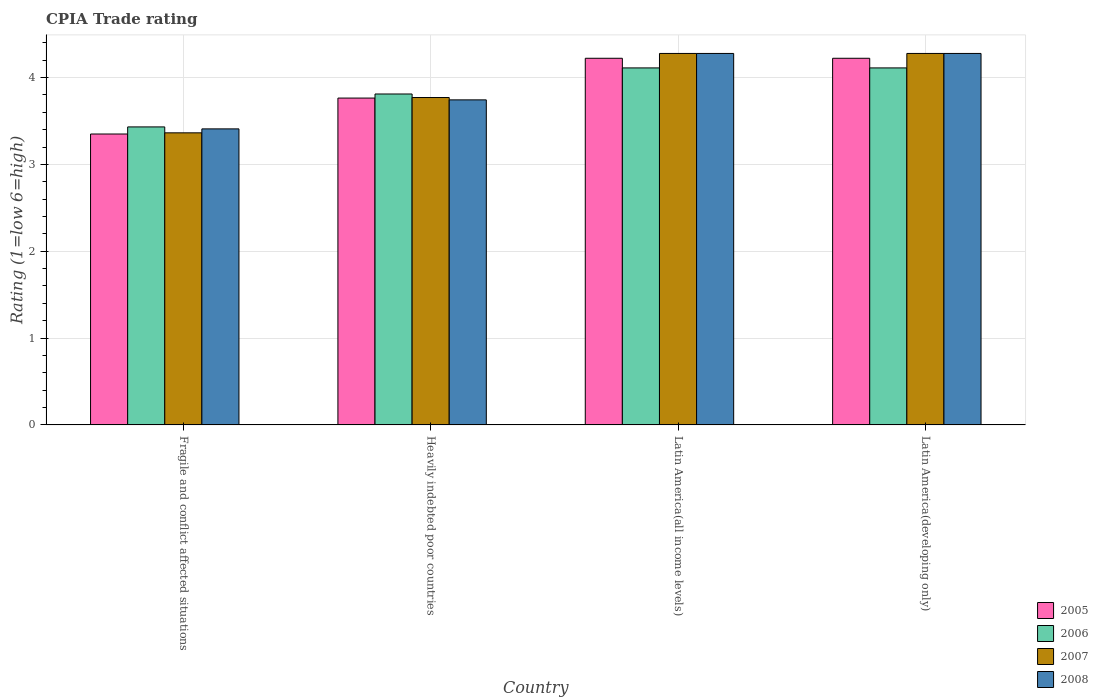How many different coloured bars are there?
Provide a succinct answer. 4. Are the number of bars per tick equal to the number of legend labels?
Provide a succinct answer. Yes. Are the number of bars on each tick of the X-axis equal?
Make the answer very short. Yes. How many bars are there on the 4th tick from the right?
Make the answer very short. 4. What is the label of the 4th group of bars from the left?
Give a very brief answer. Latin America(developing only). What is the CPIA rating in 2006 in Latin America(developing only)?
Provide a short and direct response. 4.11. Across all countries, what is the maximum CPIA rating in 2008?
Keep it short and to the point. 4.28. Across all countries, what is the minimum CPIA rating in 2006?
Your answer should be very brief. 3.43. In which country was the CPIA rating in 2008 maximum?
Offer a very short reply. Latin America(all income levels). In which country was the CPIA rating in 2005 minimum?
Provide a succinct answer. Fragile and conflict affected situations. What is the total CPIA rating in 2005 in the graph?
Your answer should be very brief. 15.56. What is the difference between the CPIA rating in 2007 in Heavily indebted poor countries and that in Latin America(developing only)?
Ensure brevity in your answer.  -0.51. What is the difference between the CPIA rating in 2006 in Fragile and conflict affected situations and the CPIA rating in 2007 in Latin America(all income levels)?
Your answer should be compact. -0.85. What is the average CPIA rating in 2008 per country?
Provide a short and direct response. 3.93. What is the difference between the CPIA rating of/in 2008 and CPIA rating of/in 2005 in Heavily indebted poor countries?
Your answer should be very brief. -0.02. In how many countries, is the CPIA rating in 2005 greater than 0.4?
Make the answer very short. 4. What is the ratio of the CPIA rating in 2006 in Fragile and conflict affected situations to that in Latin America(all income levels)?
Provide a succinct answer. 0.83. Is the difference between the CPIA rating in 2008 in Fragile and conflict affected situations and Latin America(all income levels) greater than the difference between the CPIA rating in 2005 in Fragile and conflict affected situations and Latin America(all income levels)?
Your answer should be compact. Yes. What is the difference between the highest and the second highest CPIA rating in 2008?
Your answer should be very brief. -0.53. What is the difference between the highest and the lowest CPIA rating in 2007?
Give a very brief answer. 0.91. In how many countries, is the CPIA rating in 2008 greater than the average CPIA rating in 2008 taken over all countries?
Keep it short and to the point. 2. What does the 3rd bar from the right in Latin America(all income levels) represents?
Make the answer very short. 2006. Is it the case that in every country, the sum of the CPIA rating in 2006 and CPIA rating in 2008 is greater than the CPIA rating in 2005?
Your answer should be very brief. Yes. How many bars are there?
Your answer should be very brief. 16. How many countries are there in the graph?
Offer a very short reply. 4. What is the difference between two consecutive major ticks on the Y-axis?
Give a very brief answer. 1. Does the graph contain any zero values?
Your answer should be very brief. No. How many legend labels are there?
Make the answer very short. 4. What is the title of the graph?
Make the answer very short. CPIA Trade rating. Does "1988" appear as one of the legend labels in the graph?
Offer a terse response. No. What is the label or title of the X-axis?
Keep it short and to the point. Country. What is the Rating (1=low 6=high) in 2005 in Fragile and conflict affected situations?
Your answer should be compact. 3.35. What is the Rating (1=low 6=high) of 2006 in Fragile and conflict affected situations?
Offer a terse response. 3.43. What is the Rating (1=low 6=high) of 2007 in Fragile and conflict affected situations?
Offer a terse response. 3.36. What is the Rating (1=low 6=high) in 2008 in Fragile and conflict affected situations?
Make the answer very short. 3.41. What is the Rating (1=low 6=high) in 2005 in Heavily indebted poor countries?
Provide a short and direct response. 3.76. What is the Rating (1=low 6=high) in 2006 in Heavily indebted poor countries?
Give a very brief answer. 3.81. What is the Rating (1=low 6=high) of 2007 in Heavily indebted poor countries?
Your answer should be very brief. 3.77. What is the Rating (1=low 6=high) in 2008 in Heavily indebted poor countries?
Offer a very short reply. 3.74. What is the Rating (1=low 6=high) of 2005 in Latin America(all income levels)?
Offer a terse response. 4.22. What is the Rating (1=low 6=high) in 2006 in Latin America(all income levels)?
Ensure brevity in your answer.  4.11. What is the Rating (1=low 6=high) in 2007 in Latin America(all income levels)?
Ensure brevity in your answer.  4.28. What is the Rating (1=low 6=high) in 2008 in Latin America(all income levels)?
Offer a very short reply. 4.28. What is the Rating (1=low 6=high) of 2005 in Latin America(developing only)?
Ensure brevity in your answer.  4.22. What is the Rating (1=low 6=high) of 2006 in Latin America(developing only)?
Offer a very short reply. 4.11. What is the Rating (1=low 6=high) in 2007 in Latin America(developing only)?
Your answer should be compact. 4.28. What is the Rating (1=low 6=high) of 2008 in Latin America(developing only)?
Offer a terse response. 4.28. Across all countries, what is the maximum Rating (1=low 6=high) of 2005?
Keep it short and to the point. 4.22. Across all countries, what is the maximum Rating (1=low 6=high) in 2006?
Ensure brevity in your answer.  4.11. Across all countries, what is the maximum Rating (1=low 6=high) in 2007?
Offer a terse response. 4.28. Across all countries, what is the maximum Rating (1=low 6=high) in 2008?
Provide a short and direct response. 4.28. Across all countries, what is the minimum Rating (1=low 6=high) of 2005?
Give a very brief answer. 3.35. Across all countries, what is the minimum Rating (1=low 6=high) in 2006?
Ensure brevity in your answer.  3.43. Across all countries, what is the minimum Rating (1=low 6=high) of 2007?
Provide a short and direct response. 3.36. Across all countries, what is the minimum Rating (1=low 6=high) in 2008?
Provide a short and direct response. 3.41. What is the total Rating (1=low 6=high) in 2005 in the graph?
Your answer should be compact. 15.56. What is the total Rating (1=low 6=high) in 2006 in the graph?
Provide a short and direct response. 15.46. What is the total Rating (1=low 6=high) in 2007 in the graph?
Offer a terse response. 15.69. What is the total Rating (1=low 6=high) in 2008 in the graph?
Your answer should be compact. 15.71. What is the difference between the Rating (1=low 6=high) in 2005 in Fragile and conflict affected situations and that in Heavily indebted poor countries?
Provide a short and direct response. -0.41. What is the difference between the Rating (1=low 6=high) of 2006 in Fragile and conflict affected situations and that in Heavily indebted poor countries?
Keep it short and to the point. -0.38. What is the difference between the Rating (1=low 6=high) of 2007 in Fragile and conflict affected situations and that in Heavily indebted poor countries?
Your answer should be compact. -0.41. What is the difference between the Rating (1=low 6=high) in 2008 in Fragile and conflict affected situations and that in Heavily indebted poor countries?
Your answer should be very brief. -0.33. What is the difference between the Rating (1=low 6=high) of 2005 in Fragile and conflict affected situations and that in Latin America(all income levels)?
Your answer should be very brief. -0.87. What is the difference between the Rating (1=low 6=high) of 2006 in Fragile and conflict affected situations and that in Latin America(all income levels)?
Your response must be concise. -0.68. What is the difference between the Rating (1=low 6=high) of 2007 in Fragile and conflict affected situations and that in Latin America(all income levels)?
Give a very brief answer. -0.91. What is the difference between the Rating (1=low 6=high) in 2008 in Fragile and conflict affected situations and that in Latin America(all income levels)?
Your response must be concise. -0.87. What is the difference between the Rating (1=low 6=high) in 2005 in Fragile and conflict affected situations and that in Latin America(developing only)?
Provide a short and direct response. -0.87. What is the difference between the Rating (1=low 6=high) of 2006 in Fragile and conflict affected situations and that in Latin America(developing only)?
Your answer should be very brief. -0.68. What is the difference between the Rating (1=low 6=high) of 2007 in Fragile and conflict affected situations and that in Latin America(developing only)?
Provide a short and direct response. -0.91. What is the difference between the Rating (1=low 6=high) in 2008 in Fragile and conflict affected situations and that in Latin America(developing only)?
Your response must be concise. -0.87. What is the difference between the Rating (1=low 6=high) in 2005 in Heavily indebted poor countries and that in Latin America(all income levels)?
Provide a short and direct response. -0.46. What is the difference between the Rating (1=low 6=high) in 2006 in Heavily indebted poor countries and that in Latin America(all income levels)?
Provide a short and direct response. -0.3. What is the difference between the Rating (1=low 6=high) in 2007 in Heavily indebted poor countries and that in Latin America(all income levels)?
Your answer should be very brief. -0.51. What is the difference between the Rating (1=low 6=high) in 2008 in Heavily indebted poor countries and that in Latin America(all income levels)?
Your answer should be compact. -0.53. What is the difference between the Rating (1=low 6=high) of 2005 in Heavily indebted poor countries and that in Latin America(developing only)?
Your answer should be very brief. -0.46. What is the difference between the Rating (1=low 6=high) of 2006 in Heavily indebted poor countries and that in Latin America(developing only)?
Give a very brief answer. -0.3. What is the difference between the Rating (1=low 6=high) in 2007 in Heavily indebted poor countries and that in Latin America(developing only)?
Keep it short and to the point. -0.51. What is the difference between the Rating (1=low 6=high) in 2008 in Heavily indebted poor countries and that in Latin America(developing only)?
Ensure brevity in your answer.  -0.53. What is the difference between the Rating (1=low 6=high) in 2007 in Latin America(all income levels) and that in Latin America(developing only)?
Your answer should be compact. 0. What is the difference between the Rating (1=low 6=high) of 2005 in Fragile and conflict affected situations and the Rating (1=low 6=high) of 2006 in Heavily indebted poor countries?
Make the answer very short. -0.46. What is the difference between the Rating (1=low 6=high) of 2005 in Fragile and conflict affected situations and the Rating (1=low 6=high) of 2007 in Heavily indebted poor countries?
Provide a succinct answer. -0.42. What is the difference between the Rating (1=low 6=high) of 2005 in Fragile and conflict affected situations and the Rating (1=low 6=high) of 2008 in Heavily indebted poor countries?
Provide a short and direct response. -0.39. What is the difference between the Rating (1=low 6=high) of 2006 in Fragile and conflict affected situations and the Rating (1=low 6=high) of 2007 in Heavily indebted poor countries?
Offer a terse response. -0.34. What is the difference between the Rating (1=low 6=high) in 2006 in Fragile and conflict affected situations and the Rating (1=low 6=high) in 2008 in Heavily indebted poor countries?
Offer a terse response. -0.31. What is the difference between the Rating (1=low 6=high) of 2007 in Fragile and conflict affected situations and the Rating (1=low 6=high) of 2008 in Heavily indebted poor countries?
Your response must be concise. -0.38. What is the difference between the Rating (1=low 6=high) in 2005 in Fragile and conflict affected situations and the Rating (1=low 6=high) in 2006 in Latin America(all income levels)?
Provide a short and direct response. -0.76. What is the difference between the Rating (1=low 6=high) of 2005 in Fragile and conflict affected situations and the Rating (1=low 6=high) of 2007 in Latin America(all income levels)?
Provide a short and direct response. -0.93. What is the difference between the Rating (1=low 6=high) of 2005 in Fragile and conflict affected situations and the Rating (1=low 6=high) of 2008 in Latin America(all income levels)?
Make the answer very short. -0.93. What is the difference between the Rating (1=low 6=high) of 2006 in Fragile and conflict affected situations and the Rating (1=low 6=high) of 2007 in Latin America(all income levels)?
Give a very brief answer. -0.85. What is the difference between the Rating (1=low 6=high) of 2006 in Fragile and conflict affected situations and the Rating (1=low 6=high) of 2008 in Latin America(all income levels)?
Provide a short and direct response. -0.85. What is the difference between the Rating (1=low 6=high) in 2007 in Fragile and conflict affected situations and the Rating (1=low 6=high) in 2008 in Latin America(all income levels)?
Ensure brevity in your answer.  -0.91. What is the difference between the Rating (1=low 6=high) of 2005 in Fragile and conflict affected situations and the Rating (1=low 6=high) of 2006 in Latin America(developing only)?
Keep it short and to the point. -0.76. What is the difference between the Rating (1=low 6=high) in 2005 in Fragile and conflict affected situations and the Rating (1=low 6=high) in 2007 in Latin America(developing only)?
Make the answer very short. -0.93. What is the difference between the Rating (1=low 6=high) in 2005 in Fragile and conflict affected situations and the Rating (1=low 6=high) in 2008 in Latin America(developing only)?
Your response must be concise. -0.93. What is the difference between the Rating (1=low 6=high) in 2006 in Fragile and conflict affected situations and the Rating (1=low 6=high) in 2007 in Latin America(developing only)?
Provide a short and direct response. -0.85. What is the difference between the Rating (1=low 6=high) in 2006 in Fragile and conflict affected situations and the Rating (1=low 6=high) in 2008 in Latin America(developing only)?
Your response must be concise. -0.85. What is the difference between the Rating (1=low 6=high) in 2007 in Fragile and conflict affected situations and the Rating (1=low 6=high) in 2008 in Latin America(developing only)?
Give a very brief answer. -0.91. What is the difference between the Rating (1=low 6=high) of 2005 in Heavily indebted poor countries and the Rating (1=low 6=high) of 2006 in Latin America(all income levels)?
Keep it short and to the point. -0.35. What is the difference between the Rating (1=low 6=high) in 2005 in Heavily indebted poor countries and the Rating (1=low 6=high) in 2007 in Latin America(all income levels)?
Your response must be concise. -0.51. What is the difference between the Rating (1=low 6=high) of 2005 in Heavily indebted poor countries and the Rating (1=low 6=high) of 2008 in Latin America(all income levels)?
Provide a succinct answer. -0.51. What is the difference between the Rating (1=low 6=high) in 2006 in Heavily indebted poor countries and the Rating (1=low 6=high) in 2007 in Latin America(all income levels)?
Your response must be concise. -0.47. What is the difference between the Rating (1=low 6=high) of 2006 in Heavily indebted poor countries and the Rating (1=low 6=high) of 2008 in Latin America(all income levels)?
Your answer should be very brief. -0.47. What is the difference between the Rating (1=low 6=high) in 2007 in Heavily indebted poor countries and the Rating (1=low 6=high) in 2008 in Latin America(all income levels)?
Ensure brevity in your answer.  -0.51. What is the difference between the Rating (1=low 6=high) of 2005 in Heavily indebted poor countries and the Rating (1=low 6=high) of 2006 in Latin America(developing only)?
Give a very brief answer. -0.35. What is the difference between the Rating (1=low 6=high) of 2005 in Heavily indebted poor countries and the Rating (1=low 6=high) of 2007 in Latin America(developing only)?
Your response must be concise. -0.51. What is the difference between the Rating (1=low 6=high) in 2005 in Heavily indebted poor countries and the Rating (1=low 6=high) in 2008 in Latin America(developing only)?
Offer a terse response. -0.51. What is the difference between the Rating (1=low 6=high) of 2006 in Heavily indebted poor countries and the Rating (1=low 6=high) of 2007 in Latin America(developing only)?
Offer a very short reply. -0.47. What is the difference between the Rating (1=low 6=high) of 2006 in Heavily indebted poor countries and the Rating (1=low 6=high) of 2008 in Latin America(developing only)?
Your response must be concise. -0.47. What is the difference between the Rating (1=low 6=high) of 2007 in Heavily indebted poor countries and the Rating (1=low 6=high) of 2008 in Latin America(developing only)?
Provide a succinct answer. -0.51. What is the difference between the Rating (1=low 6=high) of 2005 in Latin America(all income levels) and the Rating (1=low 6=high) of 2007 in Latin America(developing only)?
Your answer should be compact. -0.06. What is the difference between the Rating (1=low 6=high) of 2005 in Latin America(all income levels) and the Rating (1=low 6=high) of 2008 in Latin America(developing only)?
Keep it short and to the point. -0.06. What is the difference between the Rating (1=low 6=high) in 2006 in Latin America(all income levels) and the Rating (1=low 6=high) in 2008 in Latin America(developing only)?
Your answer should be very brief. -0.17. What is the difference between the Rating (1=low 6=high) in 2007 in Latin America(all income levels) and the Rating (1=low 6=high) in 2008 in Latin America(developing only)?
Keep it short and to the point. 0. What is the average Rating (1=low 6=high) of 2005 per country?
Offer a terse response. 3.89. What is the average Rating (1=low 6=high) of 2006 per country?
Keep it short and to the point. 3.87. What is the average Rating (1=low 6=high) of 2007 per country?
Keep it short and to the point. 3.92. What is the average Rating (1=low 6=high) of 2008 per country?
Provide a short and direct response. 3.93. What is the difference between the Rating (1=low 6=high) of 2005 and Rating (1=low 6=high) of 2006 in Fragile and conflict affected situations?
Make the answer very short. -0.08. What is the difference between the Rating (1=low 6=high) in 2005 and Rating (1=low 6=high) in 2007 in Fragile and conflict affected situations?
Keep it short and to the point. -0.01. What is the difference between the Rating (1=low 6=high) of 2005 and Rating (1=low 6=high) of 2008 in Fragile and conflict affected situations?
Provide a short and direct response. -0.06. What is the difference between the Rating (1=low 6=high) in 2006 and Rating (1=low 6=high) in 2007 in Fragile and conflict affected situations?
Your response must be concise. 0.07. What is the difference between the Rating (1=low 6=high) in 2006 and Rating (1=low 6=high) in 2008 in Fragile and conflict affected situations?
Offer a terse response. 0.02. What is the difference between the Rating (1=low 6=high) of 2007 and Rating (1=low 6=high) of 2008 in Fragile and conflict affected situations?
Provide a short and direct response. -0.05. What is the difference between the Rating (1=low 6=high) in 2005 and Rating (1=low 6=high) in 2006 in Heavily indebted poor countries?
Your answer should be compact. -0.05. What is the difference between the Rating (1=low 6=high) in 2005 and Rating (1=low 6=high) in 2007 in Heavily indebted poor countries?
Ensure brevity in your answer.  -0.01. What is the difference between the Rating (1=low 6=high) in 2005 and Rating (1=low 6=high) in 2008 in Heavily indebted poor countries?
Offer a very short reply. 0.02. What is the difference between the Rating (1=low 6=high) in 2006 and Rating (1=low 6=high) in 2007 in Heavily indebted poor countries?
Provide a succinct answer. 0.04. What is the difference between the Rating (1=low 6=high) in 2006 and Rating (1=low 6=high) in 2008 in Heavily indebted poor countries?
Offer a terse response. 0.07. What is the difference between the Rating (1=low 6=high) in 2007 and Rating (1=low 6=high) in 2008 in Heavily indebted poor countries?
Your answer should be very brief. 0.03. What is the difference between the Rating (1=low 6=high) in 2005 and Rating (1=low 6=high) in 2006 in Latin America(all income levels)?
Give a very brief answer. 0.11. What is the difference between the Rating (1=low 6=high) in 2005 and Rating (1=low 6=high) in 2007 in Latin America(all income levels)?
Ensure brevity in your answer.  -0.06. What is the difference between the Rating (1=low 6=high) of 2005 and Rating (1=low 6=high) of 2008 in Latin America(all income levels)?
Ensure brevity in your answer.  -0.06. What is the difference between the Rating (1=low 6=high) in 2005 and Rating (1=low 6=high) in 2006 in Latin America(developing only)?
Provide a succinct answer. 0.11. What is the difference between the Rating (1=low 6=high) in 2005 and Rating (1=low 6=high) in 2007 in Latin America(developing only)?
Your answer should be compact. -0.06. What is the difference between the Rating (1=low 6=high) in 2005 and Rating (1=low 6=high) in 2008 in Latin America(developing only)?
Make the answer very short. -0.06. What is the difference between the Rating (1=low 6=high) in 2006 and Rating (1=low 6=high) in 2008 in Latin America(developing only)?
Provide a short and direct response. -0.17. What is the difference between the Rating (1=low 6=high) of 2007 and Rating (1=low 6=high) of 2008 in Latin America(developing only)?
Offer a terse response. 0. What is the ratio of the Rating (1=low 6=high) in 2005 in Fragile and conflict affected situations to that in Heavily indebted poor countries?
Make the answer very short. 0.89. What is the ratio of the Rating (1=low 6=high) in 2006 in Fragile and conflict affected situations to that in Heavily indebted poor countries?
Ensure brevity in your answer.  0.9. What is the ratio of the Rating (1=low 6=high) of 2007 in Fragile and conflict affected situations to that in Heavily indebted poor countries?
Provide a succinct answer. 0.89. What is the ratio of the Rating (1=low 6=high) of 2008 in Fragile and conflict affected situations to that in Heavily indebted poor countries?
Your response must be concise. 0.91. What is the ratio of the Rating (1=low 6=high) in 2005 in Fragile and conflict affected situations to that in Latin America(all income levels)?
Provide a short and direct response. 0.79. What is the ratio of the Rating (1=low 6=high) of 2006 in Fragile and conflict affected situations to that in Latin America(all income levels)?
Keep it short and to the point. 0.83. What is the ratio of the Rating (1=low 6=high) in 2007 in Fragile and conflict affected situations to that in Latin America(all income levels)?
Give a very brief answer. 0.79. What is the ratio of the Rating (1=low 6=high) in 2008 in Fragile and conflict affected situations to that in Latin America(all income levels)?
Make the answer very short. 0.8. What is the ratio of the Rating (1=low 6=high) of 2005 in Fragile and conflict affected situations to that in Latin America(developing only)?
Provide a succinct answer. 0.79. What is the ratio of the Rating (1=low 6=high) of 2006 in Fragile and conflict affected situations to that in Latin America(developing only)?
Your response must be concise. 0.83. What is the ratio of the Rating (1=low 6=high) of 2007 in Fragile and conflict affected situations to that in Latin America(developing only)?
Offer a very short reply. 0.79. What is the ratio of the Rating (1=low 6=high) in 2008 in Fragile and conflict affected situations to that in Latin America(developing only)?
Ensure brevity in your answer.  0.8. What is the ratio of the Rating (1=low 6=high) of 2005 in Heavily indebted poor countries to that in Latin America(all income levels)?
Provide a succinct answer. 0.89. What is the ratio of the Rating (1=low 6=high) of 2006 in Heavily indebted poor countries to that in Latin America(all income levels)?
Your answer should be very brief. 0.93. What is the ratio of the Rating (1=low 6=high) in 2007 in Heavily indebted poor countries to that in Latin America(all income levels)?
Keep it short and to the point. 0.88. What is the ratio of the Rating (1=low 6=high) in 2005 in Heavily indebted poor countries to that in Latin America(developing only)?
Make the answer very short. 0.89. What is the ratio of the Rating (1=low 6=high) of 2006 in Heavily indebted poor countries to that in Latin America(developing only)?
Provide a short and direct response. 0.93. What is the ratio of the Rating (1=low 6=high) of 2007 in Heavily indebted poor countries to that in Latin America(developing only)?
Your answer should be compact. 0.88. What is the ratio of the Rating (1=low 6=high) of 2008 in Heavily indebted poor countries to that in Latin America(developing only)?
Make the answer very short. 0.88. What is the ratio of the Rating (1=low 6=high) of 2005 in Latin America(all income levels) to that in Latin America(developing only)?
Offer a very short reply. 1. What is the difference between the highest and the second highest Rating (1=low 6=high) in 2007?
Your response must be concise. 0. What is the difference between the highest and the second highest Rating (1=low 6=high) in 2008?
Keep it short and to the point. 0. What is the difference between the highest and the lowest Rating (1=low 6=high) in 2005?
Make the answer very short. 0.87. What is the difference between the highest and the lowest Rating (1=low 6=high) in 2006?
Keep it short and to the point. 0.68. What is the difference between the highest and the lowest Rating (1=low 6=high) in 2007?
Provide a succinct answer. 0.91. What is the difference between the highest and the lowest Rating (1=low 6=high) of 2008?
Provide a succinct answer. 0.87. 